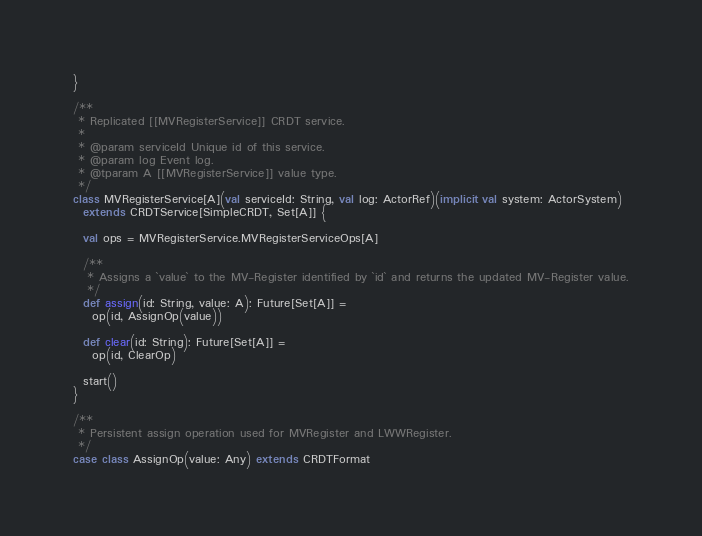<code> <loc_0><loc_0><loc_500><loc_500><_Scala_>
}

/**
 * Replicated [[MVRegisterService]] CRDT service.
 *
 * @param serviceId Unique id of this service.
 * @param log Event log.
 * @tparam A [[MVRegisterService]] value type.
 */
class MVRegisterService[A](val serviceId: String, val log: ActorRef)(implicit val system: ActorSystem)
  extends CRDTService[SimpleCRDT, Set[A]] {

  val ops = MVRegisterService.MVRegisterServiceOps[A]

  /**
   * Assigns a `value` to the MV-Register identified by `id` and returns the updated MV-Register value.
   */
  def assign(id: String, value: A): Future[Set[A]] =
    op(id, AssignOp(value))

  def clear(id: String): Future[Set[A]] =
    op(id, ClearOp)

  start()
}

/**
 * Persistent assign operation used for MVRegister and LWWRegister.
 */
case class AssignOp(value: Any) extends CRDTFormat
</code> 